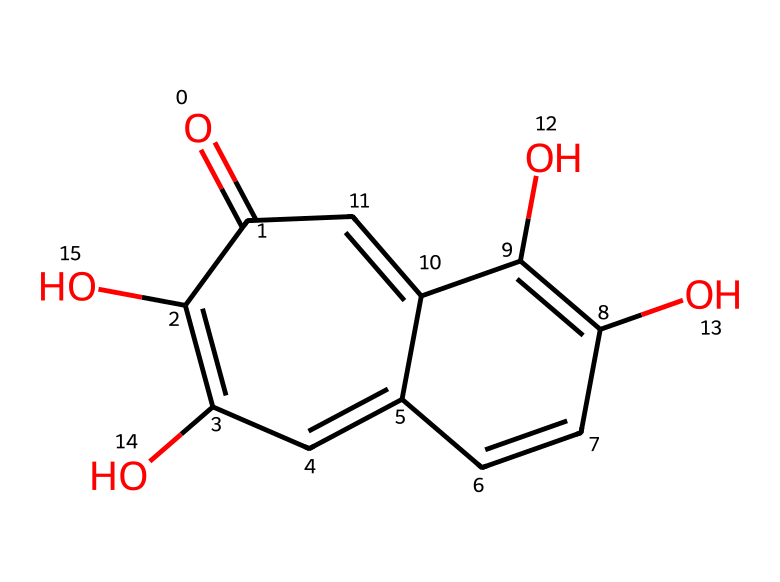What is the name of this chemical? The chemical depicted by the provided SMILES is known as chamomile extract, which contains various functional groups and a complex aromatic structure.
Answer: chamomile extract How many carbon atoms are in the molecule? By analyzing the structure, we can count the carbon atoms present in the molecule, which are represented by "C" in the SMILES notation. The total count is found to be 15.
Answer: 15 What functional groups are present in this chemical? Observing the structure reveals various functional groups, including hydroxyl (-OH) and carbonyl (C=O) groups. Identifying these can help understand the chemical's reactivity and properties.
Answer: hydroxyl, carbonyl What is the expected solubility of this compound in water? Due to the presence of multiple hydroxyl groups, which are polar and can form hydrogen bonds with water, we can infer that this compound is likely soluble in water.
Answer: soluble How does the structure of this compound relate to its calming properties? The calming properties of chamomile extract are often associated with its specific aromatic compounds and functional groups, which can interact with neurotransmitter systems in the brain. The presence of flavonoids contributes to its efficacy.
Answer: flavonoids What type of chemical is chamomile extract classified as? Chamomile extract is classified as a natural product or phytochemical, specifically categorized within the group of flavonoids and terpenes based on its structure and origin.
Answer: natural product Which part of the chemical structure is responsible for its antioxidant properties? The presence of multiple hydroxyl groups in the structure contributes to its ability to donate electrons, acting as antioxidants and protecting cells from damage. This feature is important for its therapeutic effects.
Answer: hydroxyl groups 